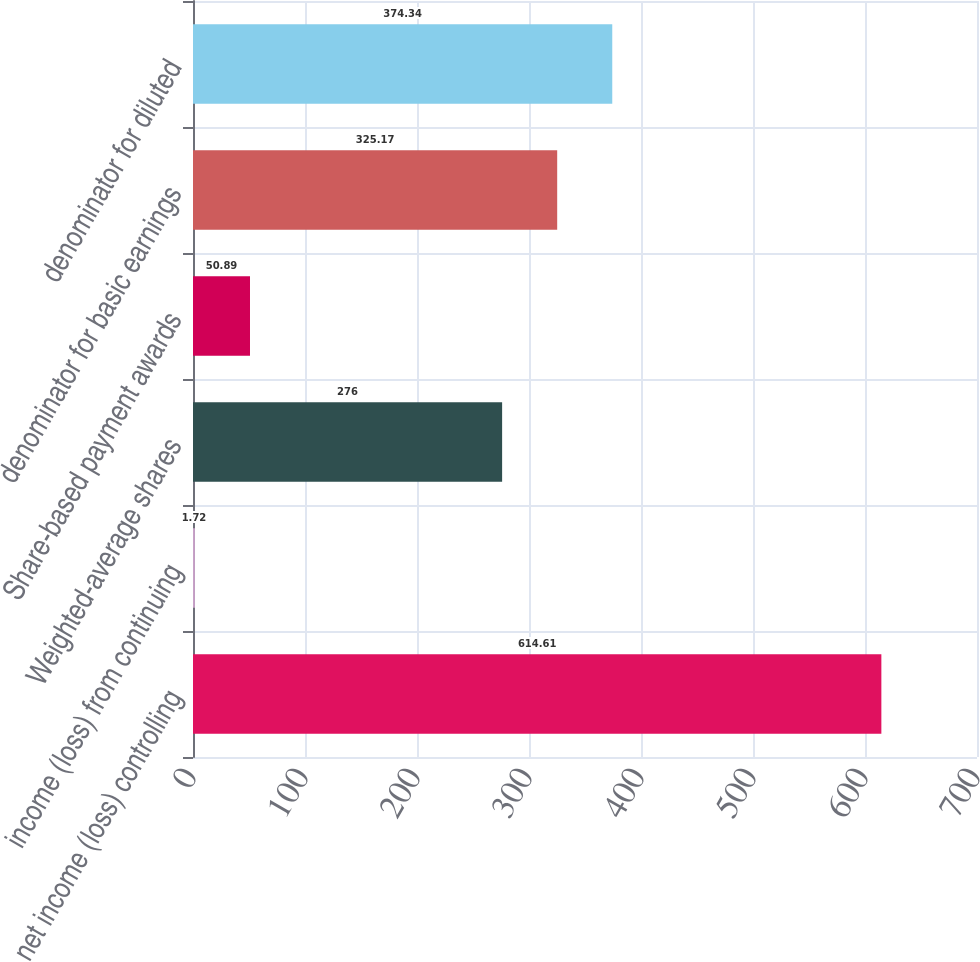<chart> <loc_0><loc_0><loc_500><loc_500><bar_chart><fcel>net income (loss) controlling<fcel>income (loss) from continuing<fcel>Weighted-average shares<fcel>Share-based payment awards<fcel>denominator for basic earnings<fcel>denominator for diluted<nl><fcel>614.61<fcel>1.72<fcel>276<fcel>50.89<fcel>325.17<fcel>374.34<nl></chart> 